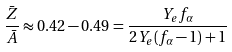<formula> <loc_0><loc_0><loc_500><loc_500>\frac { \bar { Z } } { \bar { A } } \approx 0 . 4 2 - 0 . 4 9 = \frac { Y _ { e } f _ { \alpha } } { 2 Y _ { e } ( f _ { \alpha } - 1 ) + 1 }</formula> 